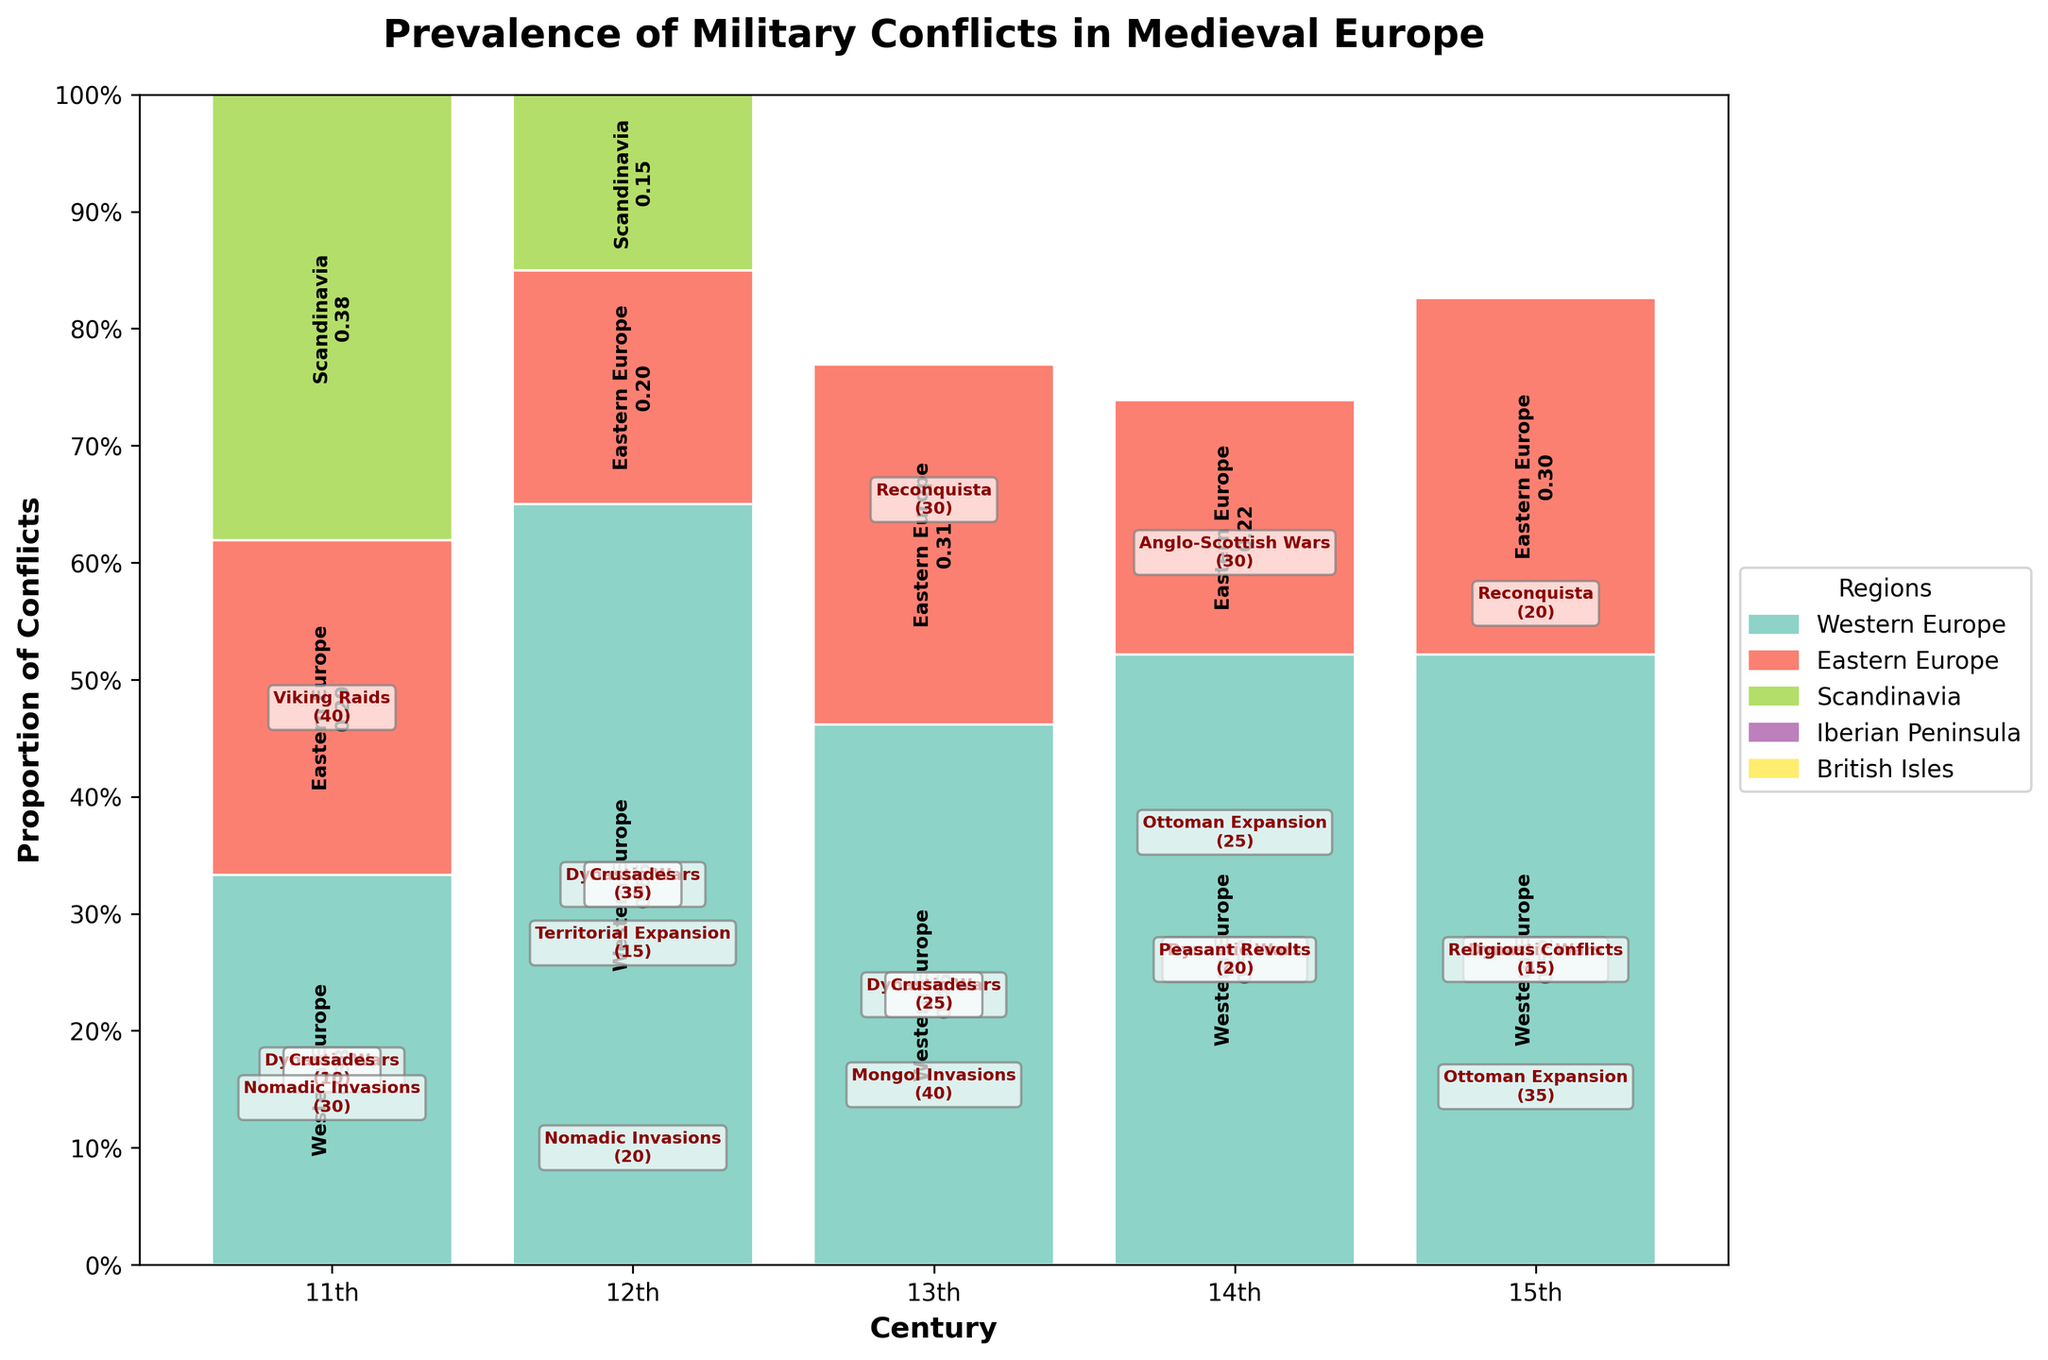Which century depicts the highest prevalence of military conflicts? The plot's y-axis shows proportion of conflicts, and the highest total height corresponds to the 15th century.
Answer: 15th century Which region has the highest proportion of conflicts in the 11th century? In the 11th-century column, the region with the largest segment is Scandinavia, which visually appears the longest in the plot.
Answer: Scandinavia How does the prevalence of 'Dynastic Wars' in Western Europe change over time? From the annotations: Western Europe sees an increase in 'Dynastic Wars' from 25 in the 11th century to 30 in the 12th, 35 in the 13th, 40 in the 14th, then 45 in the 15th century.
Answer: It increases steadily Compare the prevalence of 'Crusades' in the 12th and 13th centuries. The annotations show that the frequency of Crusades is 35 in the 12th century and decrease to 25 in the 13th century.
Answer: Crusades decrease from 35 to 25 Which region experienced the most diverse types of conflicts? Observing the annotations in the plot, Western Europe notes different types in every century, including dynastic wars, crusades, peasant revolts, and religious conflicts.
Answer: Western Europe In which century does the 'Reconquista' appear in the Iberian Peninsula and how does its frequency change? It appears in the 13th century with a frequency of 30 and decreases to 20 in the 15th century; annotations and bar heights support this.
Answer: 13th and 15th centuries, decreases from 30 to 20 Which conflict type in Eastern Europe shows an increase from the 12th to the 15th century? The plot illustrates that 'Ottoman Expansion' in Eastern Europe shows a pattern of increasing from 25 in the 14th century to 35 in the 15th century.
Answer: Ottoman Expansion How did Viking Raids in Scandinavia change from the 11th century onward? Viking Raids only appear in the 11th century with a frequency of 40 and do not appear in subsequent centuries, as reflected in the annotations.
Answer: They do not reappear after the 11th century What are the proportions of Peasant Revolts in the 14th century? From the plot's visual segments, Peasant Revolts comprise a segment in Western Europe roughly 20% of the total height for the 14th-century column.
Answer: About 20% Between the 14th and 15th centuries, which region's conflict type proportion decreases? Iberian Peninsula's 'Reconquista' frequency decreases from 30 to 20, and this is portrayed by a smaller segment in the ensuing century.
Answer: Iberian Peninsula 